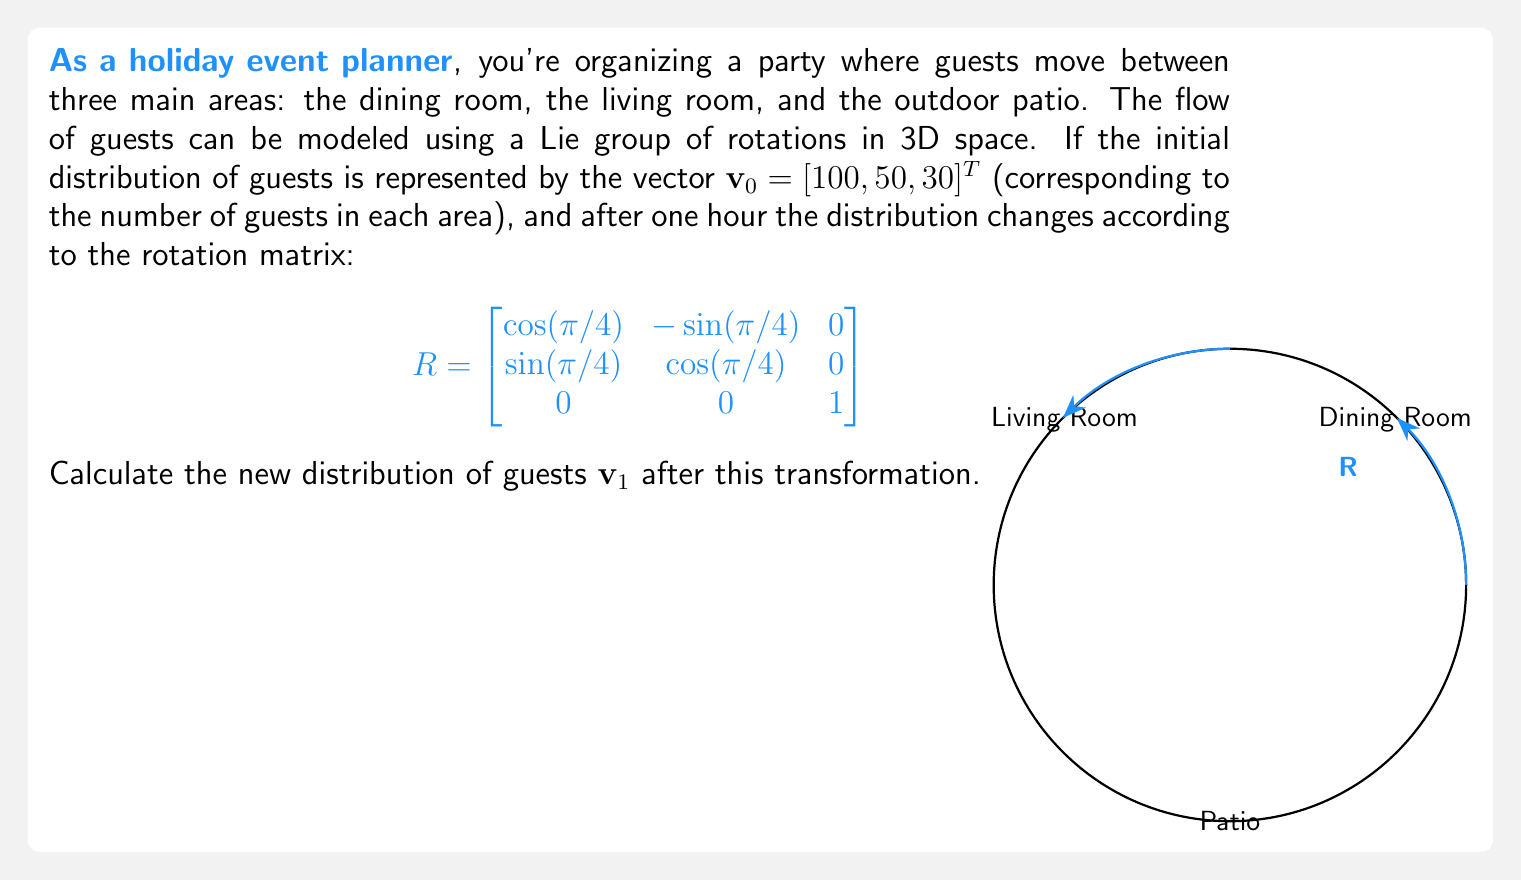Show me your answer to this math problem. To solve this problem, we need to apply the Lie group transformation (rotation matrix) to the initial distribution vector. Here's the step-by-step solution:

1) We are given the initial distribution vector $\mathbf{v}_0 = [100, 50, 30]^T$ and the rotation matrix $R$.

2) The new distribution $\mathbf{v}_1$ is obtained by multiplying $R$ and $\mathbf{v}_0$:

   $\mathbf{v}_1 = R\mathbf{v}_0$

3) Let's perform the matrix multiplication:

   $$\begin{bmatrix}
   \cos(\pi/4) & -\sin(\pi/4) & 0 \\
   \sin(\pi/4) & \cos(\pi/4) & 0 \\
   0 & 0 & 1
   \end{bmatrix} \begin{bmatrix}
   100 \\
   50 \\
   30
   \end{bmatrix}$$

4) Calculate the components:
   
   First component: $100\cos(\pi/4) - 50\sin(\pi/4) = 100\cdot\frac{\sqrt{2}}{2} - 50\cdot\frac{\sqrt{2}}{2} = 35.36$
   
   Second component: $100\sin(\pi/4) + 50\cos(\pi/4) = 100\cdot\frac{\sqrt{2}}{2} + 50\cdot\frac{\sqrt{2}}{2} = 106.07$
   
   Third component: $30 \cdot 1 = 30$

5) Therefore, the new distribution vector is:

   $\mathbf{v}_1 = [35.36, 106.07, 30]^T$

This result shows how the guests have redistributed among the three areas after one hour, according to the Lie group transformation.
Answer: $\mathbf{v}_1 = [35.36, 106.07, 30]^T$ 